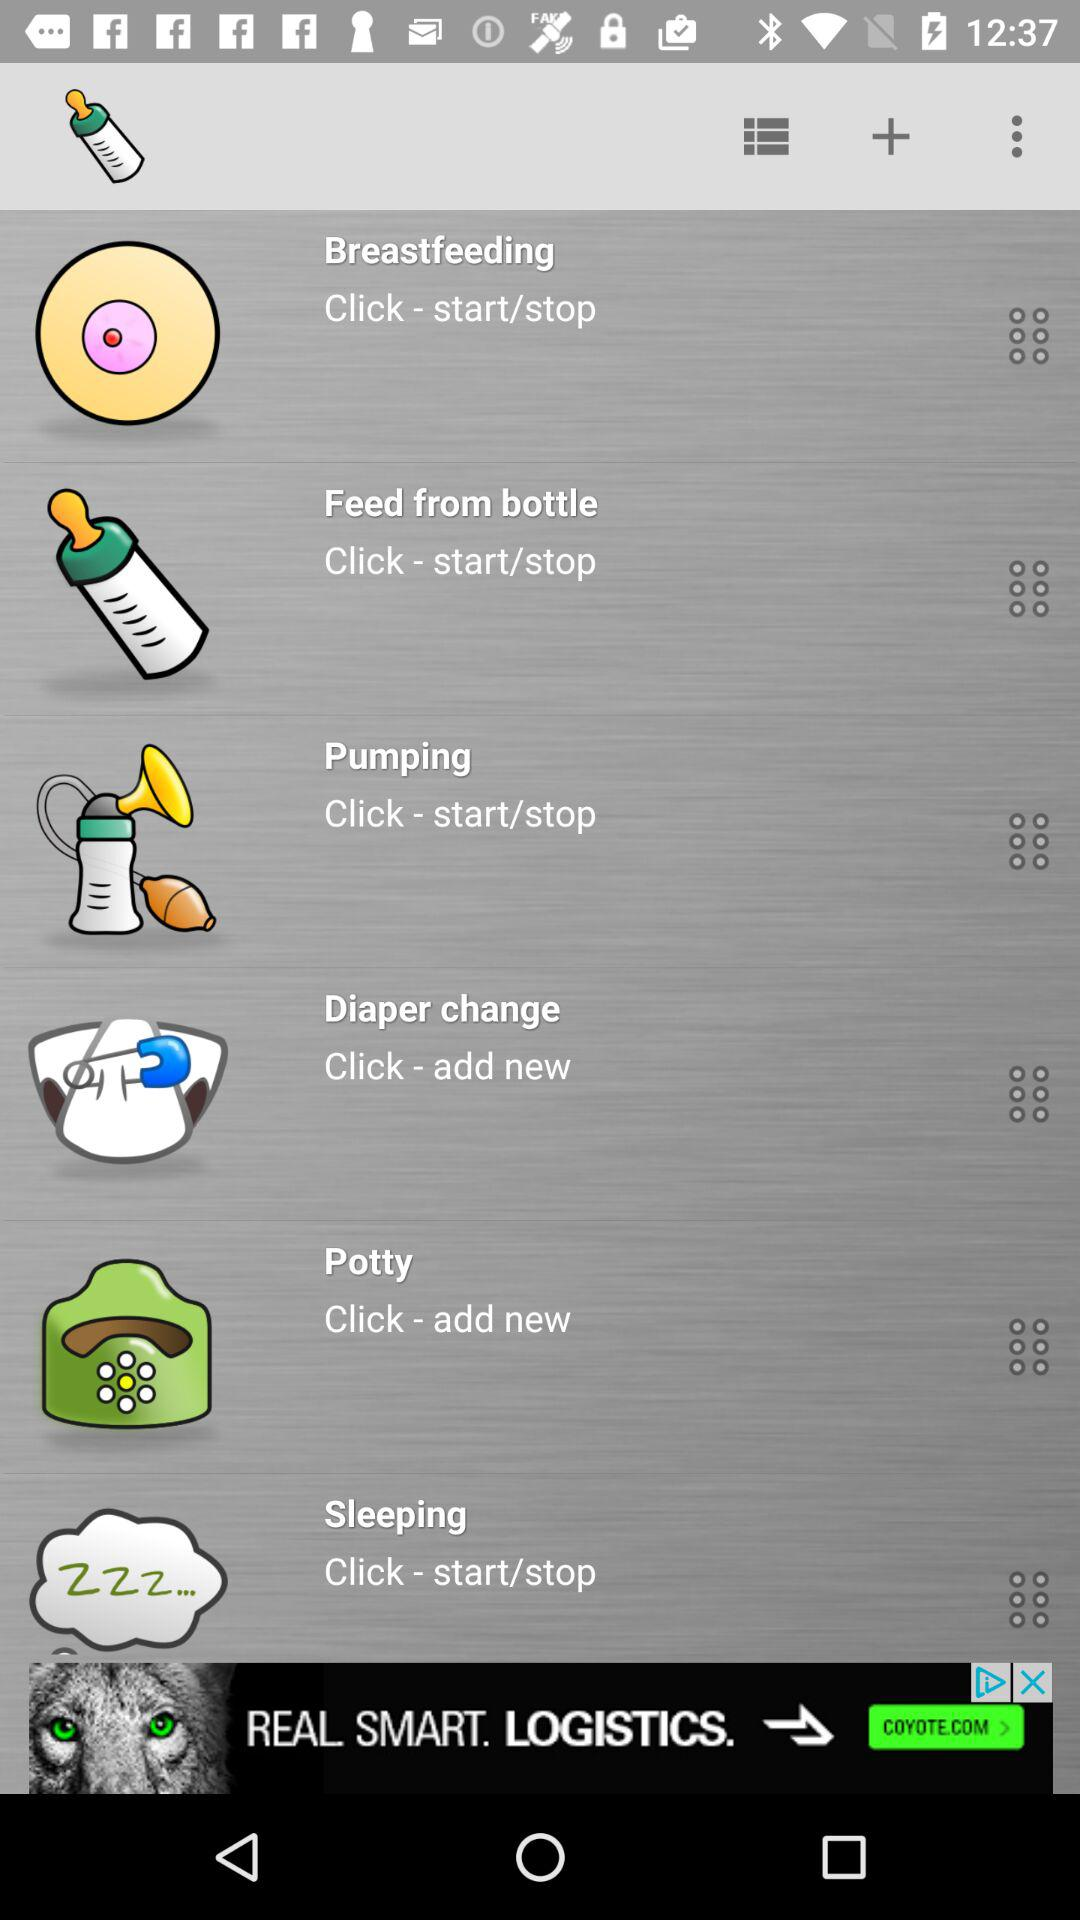How many types of activity can be tracked?
Answer the question using a single word or phrase. 6 